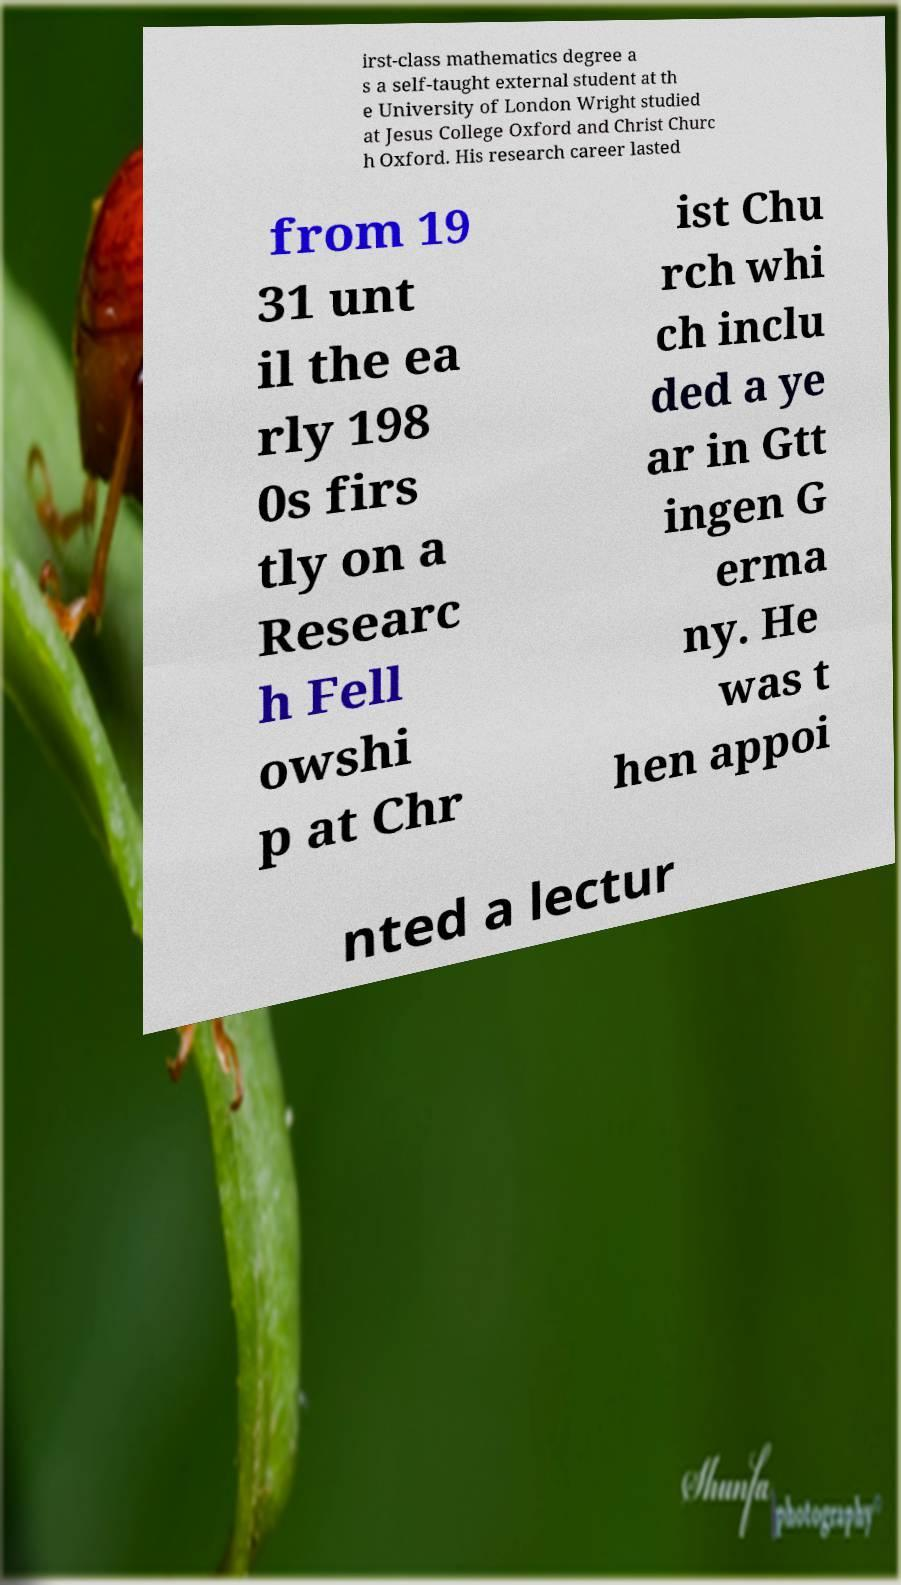There's text embedded in this image that I need extracted. Can you transcribe it verbatim? irst-class mathematics degree a s a self-taught external student at th e University of London Wright studied at Jesus College Oxford and Christ Churc h Oxford. His research career lasted from 19 31 unt il the ea rly 198 0s firs tly on a Researc h Fell owshi p at Chr ist Chu rch whi ch inclu ded a ye ar in Gtt ingen G erma ny. He was t hen appoi nted a lectur 